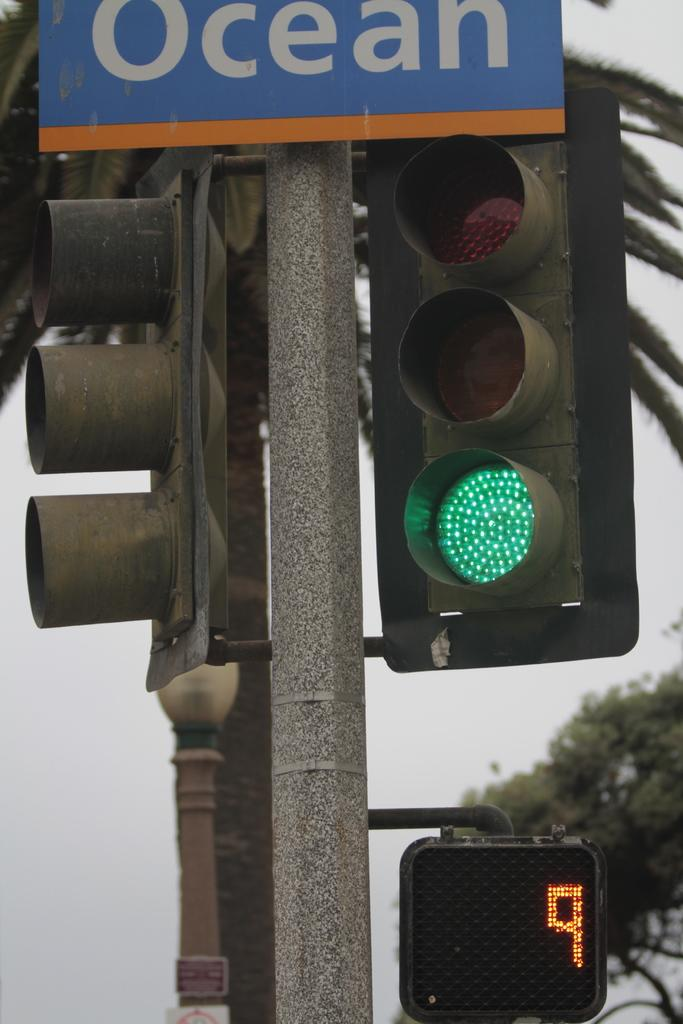Provide a one-sentence caption for the provided image. A traffic light that is on green and beneath it a sign with the number 9 showing. 